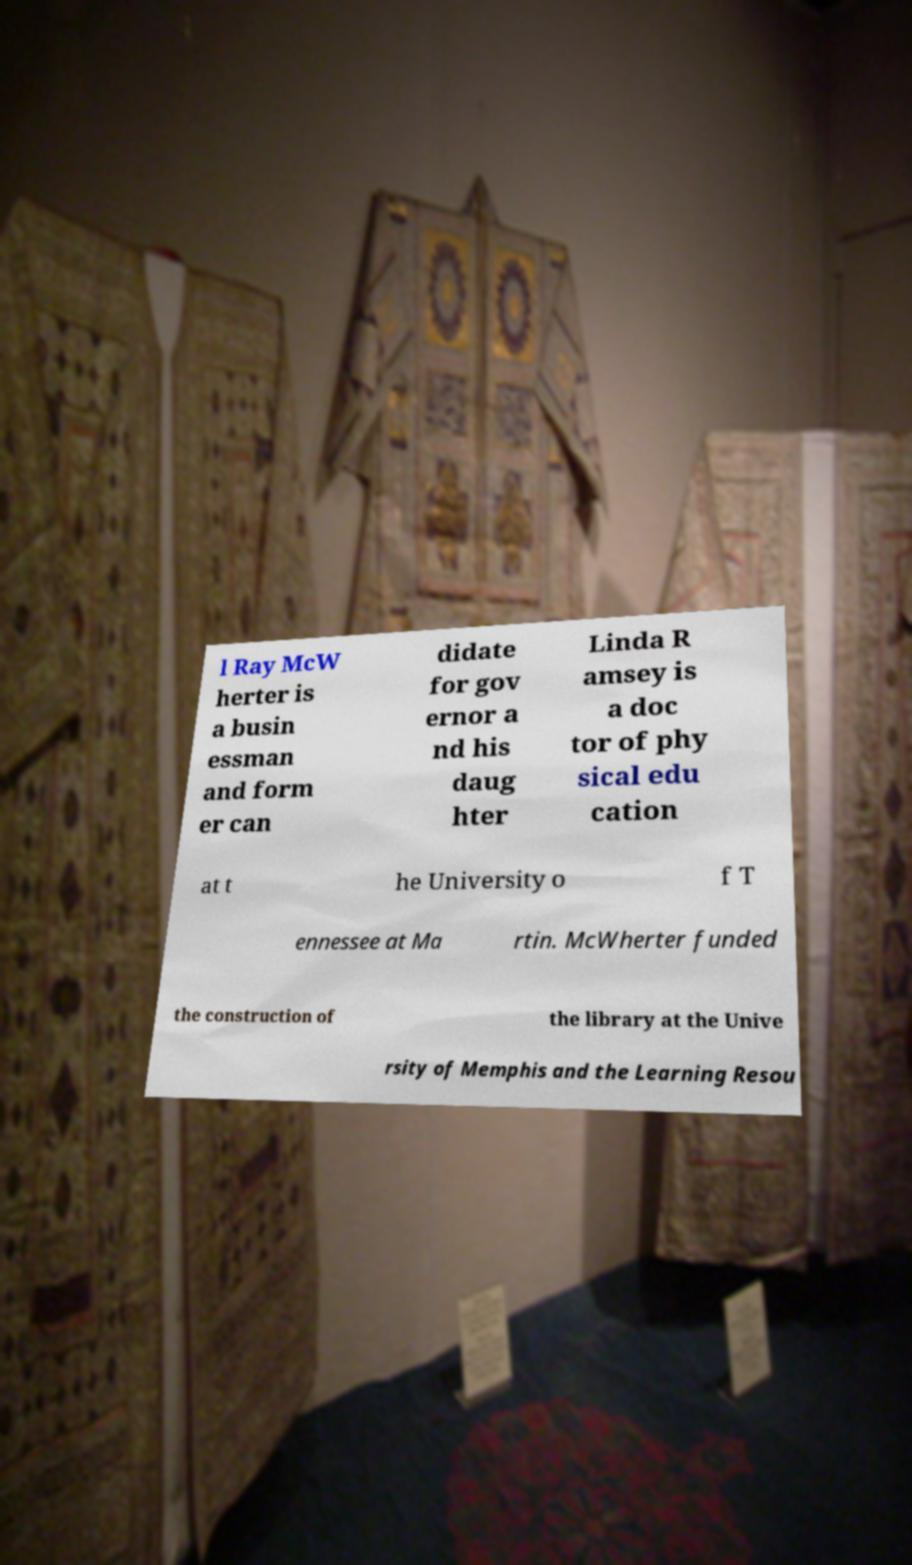What messages or text are displayed in this image? I need them in a readable, typed format. l Ray McW herter is a busin essman and form er can didate for gov ernor a nd his daug hter Linda R amsey is a doc tor of phy sical edu cation at t he University o f T ennessee at Ma rtin. McWherter funded the construction of the library at the Unive rsity of Memphis and the Learning Resou 